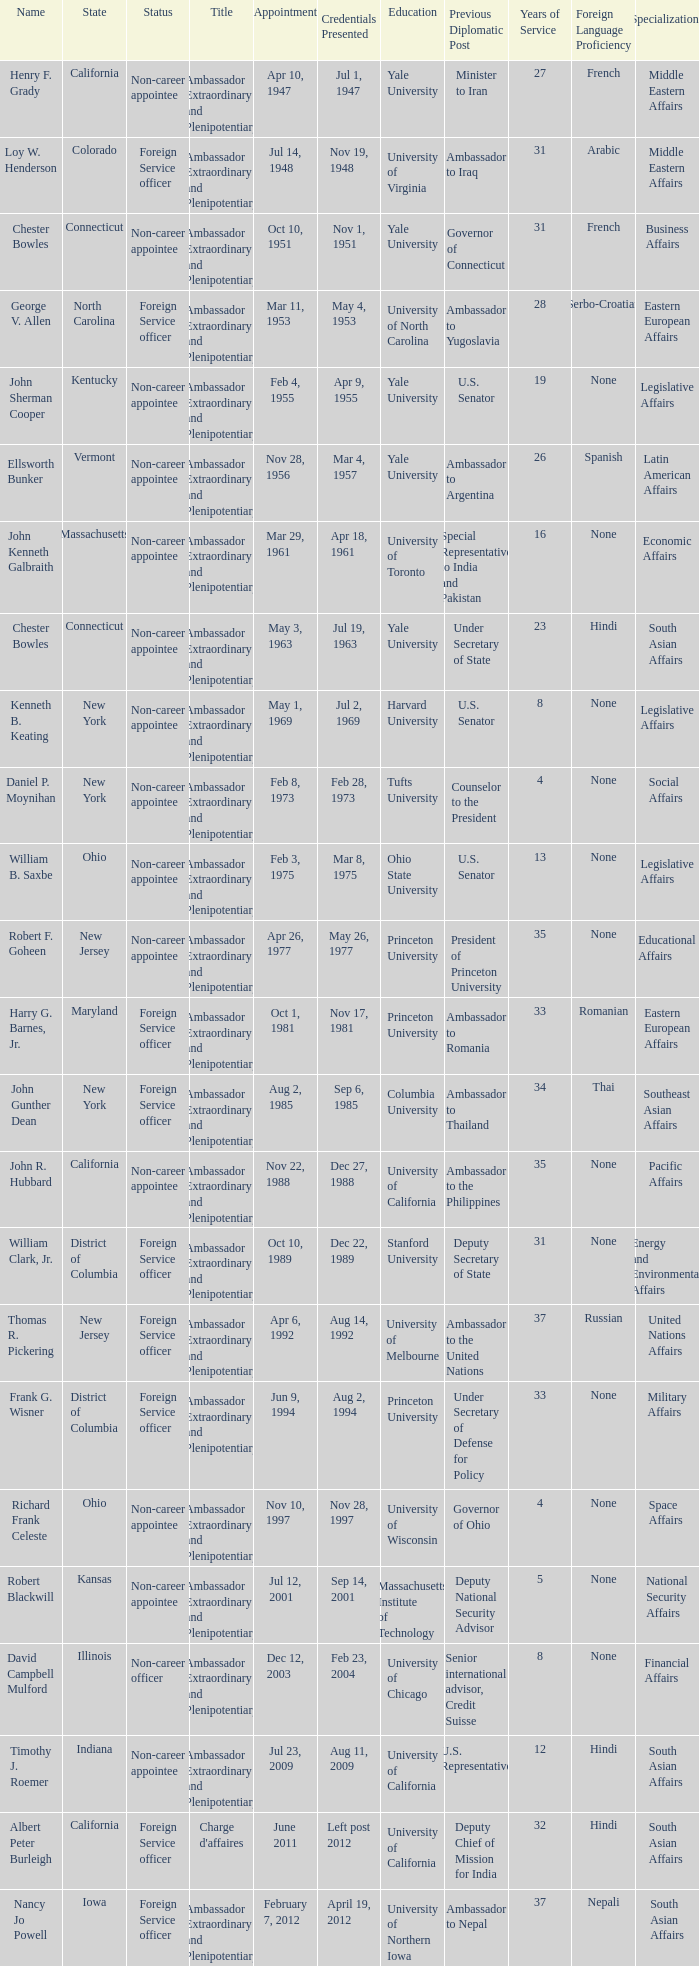What day was the appointment when Credentials Presented was jul 2, 1969? May 1, 1969. Could you parse the entire table? {'header': ['Name', 'State', 'Status', 'Title', 'Appointment', 'Credentials Presented', 'Education', 'Previous Diplomatic Post', 'Years of Service', 'Foreign Language Proficiency', 'Specializations '], 'rows': [['Henry F. Grady', 'California', 'Non-career appointee', 'Ambassador Extraordinary and Plenipotentiary', 'Apr 10, 1947', 'Jul 1, 1947', 'Yale University', 'Minister to Iran', '27', 'French', 'Middle Eastern Affairs '], ['Loy W. Henderson', 'Colorado', 'Foreign Service officer', 'Ambassador Extraordinary and Plenipotentiary', 'Jul 14, 1948', 'Nov 19, 1948', 'University of Virginia', 'Ambassador to Iraq', '31', 'Arabic', 'Middle Eastern Affairs '], ['Chester Bowles', 'Connecticut', 'Non-career appointee', 'Ambassador Extraordinary and Plenipotentiary', 'Oct 10, 1951', 'Nov 1, 1951', 'Yale University', 'Governor of Connecticut', '31', 'French', 'Business Affairs '], ['George V. Allen', 'North Carolina', 'Foreign Service officer', 'Ambassador Extraordinary and Plenipotentiary', 'Mar 11, 1953', 'May 4, 1953', 'University of North Carolina', 'Ambassador to Yugoslavia', '28', 'Serbo-Croatian', 'Eastern European Affairs '], ['John Sherman Cooper', 'Kentucky', 'Non-career appointee', 'Ambassador Extraordinary and Plenipotentiary', 'Feb 4, 1955', 'Apr 9, 1955', 'Yale University', 'U.S. Senator', '19', 'None', 'Legislative Affairs '], ['Ellsworth Bunker', 'Vermont', 'Non-career appointee', 'Ambassador Extraordinary and Plenipotentiary', 'Nov 28, 1956', 'Mar 4, 1957', 'Yale University', 'Ambassador to Argentina', '26', 'Spanish', 'Latin American Affairs '], ['John Kenneth Galbraith', 'Massachusetts', 'Non-career appointee', 'Ambassador Extraordinary and Plenipotentiary', 'Mar 29, 1961', 'Apr 18, 1961', 'University of Toronto', 'Special Representative to India and Pakistan', '16', 'None', 'Economic Affairs '], ['Chester Bowles', 'Connecticut', 'Non-career appointee', 'Ambassador Extraordinary and Plenipotentiary', 'May 3, 1963', 'Jul 19, 1963', 'Yale University', 'Under Secretary of State', '23', 'Hindi', 'South Asian Affairs '], ['Kenneth B. Keating', 'New York', 'Non-career appointee', 'Ambassador Extraordinary and Plenipotentiary', 'May 1, 1969', 'Jul 2, 1969', 'Harvard University', 'U.S. Senator', '8', 'None', 'Legislative Affairs '], ['Daniel P. Moynihan', 'New York', 'Non-career appointee', 'Ambassador Extraordinary and Plenipotentiary', 'Feb 8, 1973', 'Feb 28, 1973', 'Tufts University', 'Counselor to the President', '4', 'None', 'Social Affairs '], ['William B. Saxbe', 'Ohio', 'Non-career appointee', 'Ambassador Extraordinary and Plenipotentiary', 'Feb 3, 1975', 'Mar 8, 1975', 'Ohio State University', 'U.S. Senator', '13', 'None', 'Legislative Affairs '], ['Robert F. Goheen', 'New Jersey', 'Non-career appointee', 'Ambassador Extraordinary and Plenipotentiary', 'Apr 26, 1977', 'May 26, 1977', 'Princeton University', 'President of Princeton University', '35', 'None', 'Educational Affairs '], ['Harry G. Barnes, Jr.', 'Maryland', 'Foreign Service officer', 'Ambassador Extraordinary and Plenipotentiary', 'Oct 1, 1981', 'Nov 17, 1981', 'Princeton University', 'Ambassador to Romania', '33', 'Romanian', 'Eastern European Affairs '], ['John Gunther Dean', 'New York', 'Foreign Service officer', 'Ambassador Extraordinary and Plenipotentiary', 'Aug 2, 1985', 'Sep 6, 1985', 'Columbia University', 'Ambassador to Thailand', '34', 'Thai', 'Southeast Asian Affairs '], ['John R. Hubbard', 'California', 'Non-career appointee', 'Ambassador Extraordinary and Plenipotentiary', 'Nov 22, 1988', 'Dec 27, 1988', 'University of California', 'Ambassador to the Philippines', '35', 'None', 'Pacific Affairs '], ['William Clark, Jr.', 'District of Columbia', 'Foreign Service officer', 'Ambassador Extraordinary and Plenipotentiary', 'Oct 10, 1989', 'Dec 22, 1989', 'Stanford University', 'Deputy Secretary of State', '31', 'None', 'Energy and Environmental Affairs '], ['Thomas R. Pickering', 'New Jersey', 'Foreign Service officer', 'Ambassador Extraordinary and Plenipotentiary', 'Apr 6, 1992', 'Aug 14, 1992', 'University of Melbourne', 'Ambassador to the United Nations', '37', 'Russian', 'United Nations Affairs '], ['Frank G. Wisner', 'District of Columbia', 'Foreign Service officer', 'Ambassador Extraordinary and Plenipotentiary', 'Jun 9, 1994', 'Aug 2, 1994', 'Princeton University', 'Under Secretary of Defense for Policy', '33', 'None', 'Military Affairs '], ['Richard Frank Celeste', 'Ohio', 'Non-career appointee', 'Ambassador Extraordinary and Plenipotentiary', 'Nov 10, 1997', 'Nov 28, 1997', 'University of Wisconsin', 'Governor of Ohio', '4', 'None', 'Space Affairs '], ['Robert Blackwill', 'Kansas', 'Non-career appointee', 'Ambassador Extraordinary and Plenipotentiary', 'Jul 12, 2001', 'Sep 14, 2001', 'Massachusetts Institute of Technology', 'Deputy National Security Advisor', '5', 'None', 'National Security Affairs '], ['David Campbell Mulford', 'Illinois', 'Non-career officer', 'Ambassador Extraordinary and Plenipotentiary', 'Dec 12, 2003', 'Feb 23, 2004', 'University of Chicago', 'Senior international advisor, Credit Suisse', '8', 'None', 'Financial Affairs '], ['Timothy J. Roemer', 'Indiana', 'Non-career appointee', 'Ambassador Extraordinary and Plenipotentiary', 'Jul 23, 2009', 'Aug 11, 2009', 'University of California', 'U.S. Representative', '12', 'Hindi', 'South Asian Affairs '], ['Albert Peter Burleigh', 'California', 'Foreign Service officer', "Charge d'affaires", 'June 2011', 'Left post 2012', 'University of California', 'Deputy Chief of Mission for India', '32', 'Hindi', 'South Asian Affairs '], ['Nancy Jo Powell', 'Iowa', 'Foreign Service officer', 'Ambassador Extraordinary and Plenipotentiary', 'February 7, 2012', 'April 19, 2012', 'University of Northern Iowa', 'Ambassador to Nepal', '37', 'Nepali', 'South Asian Affairs']]} 